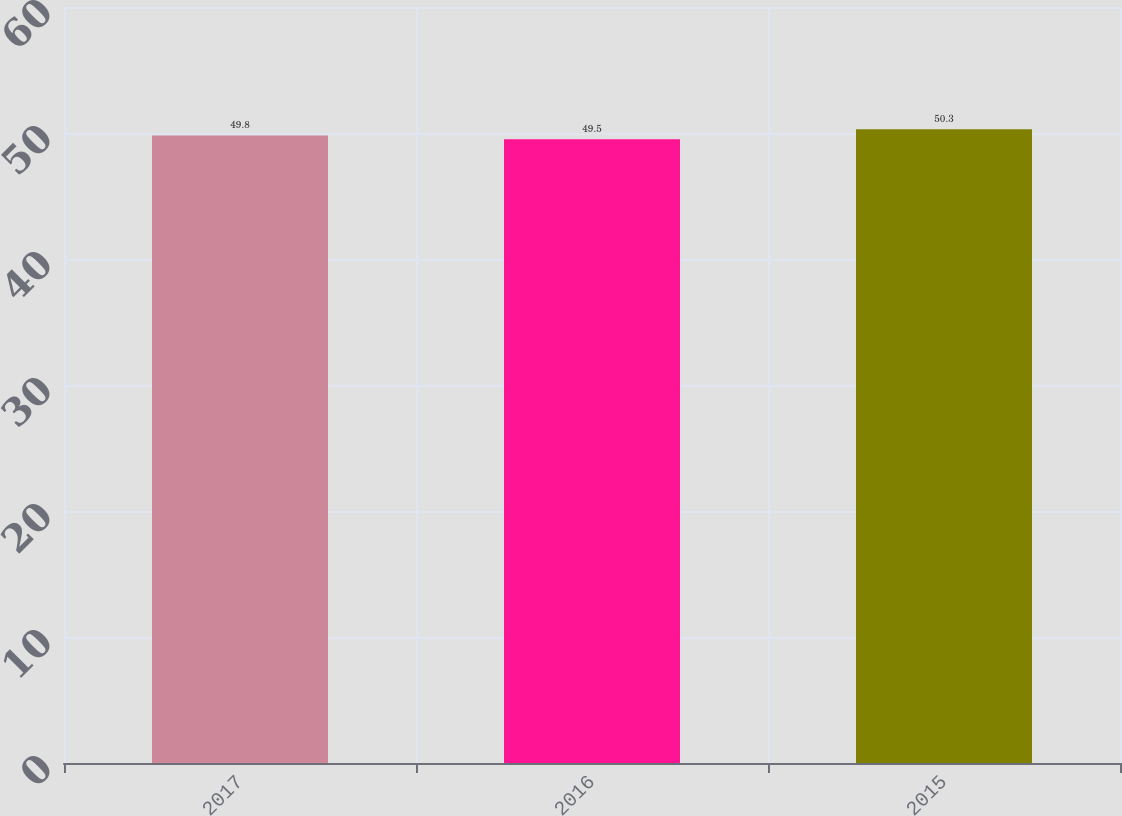Convert chart to OTSL. <chart><loc_0><loc_0><loc_500><loc_500><bar_chart><fcel>2017<fcel>2016<fcel>2015<nl><fcel>49.8<fcel>49.5<fcel>50.3<nl></chart> 